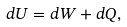Convert formula to latex. <formula><loc_0><loc_0><loc_500><loc_500>d U = d W + d Q ,</formula> 